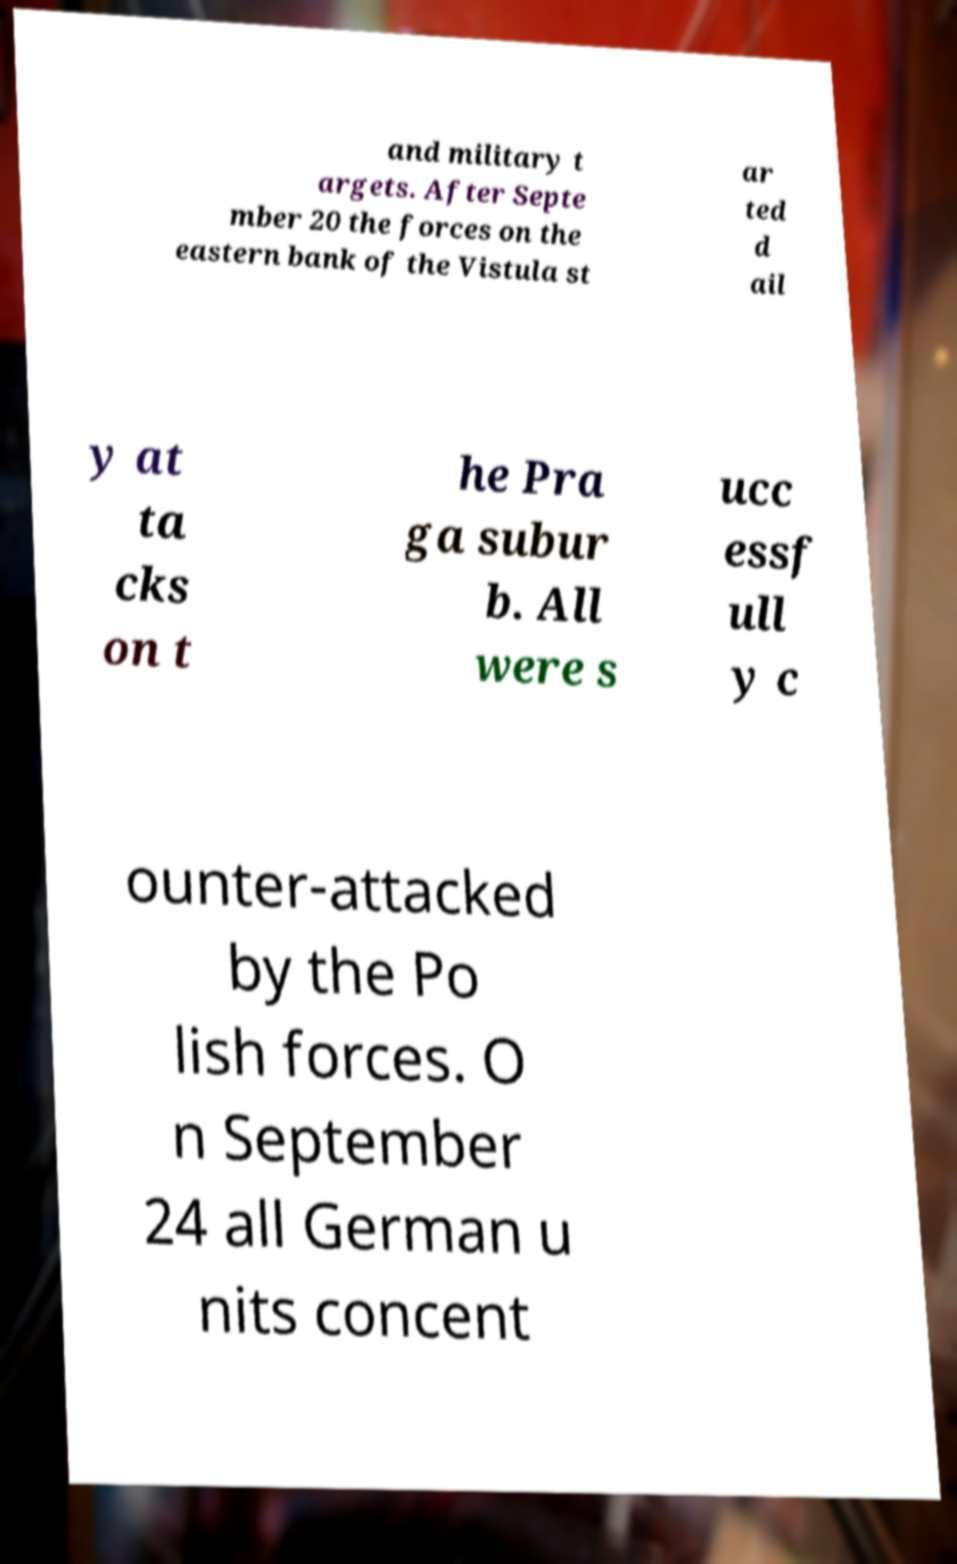Could you extract and type out the text from this image? and military t argets. After Septe mber 20 the forces on the eastern bank of the Vistula st ar ted d ail y at ta cks on t he Pra ga subur b. All were s ucc essf ull y c ounter-attacked by the Po lish forces. O n September 24 all German u nits concent 